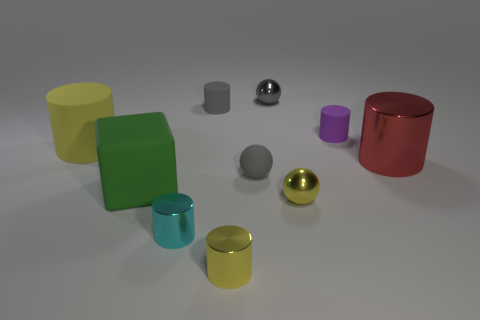How many gray balls must be subtracted to get 1 gray balls? 1 Subtract all rubber spheres. How many spheres are left? 2 Subtract all yellow balls. How many balls are left? 2 Subtract 1 blocks. How many blocks are left? 0 Subtract all green cylinders. How many cyan cubes are left? 0 Subtract all blocks. How many objects are left? 9 Subtract all blue blocks. Subtract all tiny purple things. How many objects are left? 9 Add 5 tiny purple cylinders. How many tiny purple cylinders are left? 6 Add 6 gray matte balls. How many gray matte balls exist? 7 Subtract 0 brown blocks. How many objects are left? 10 